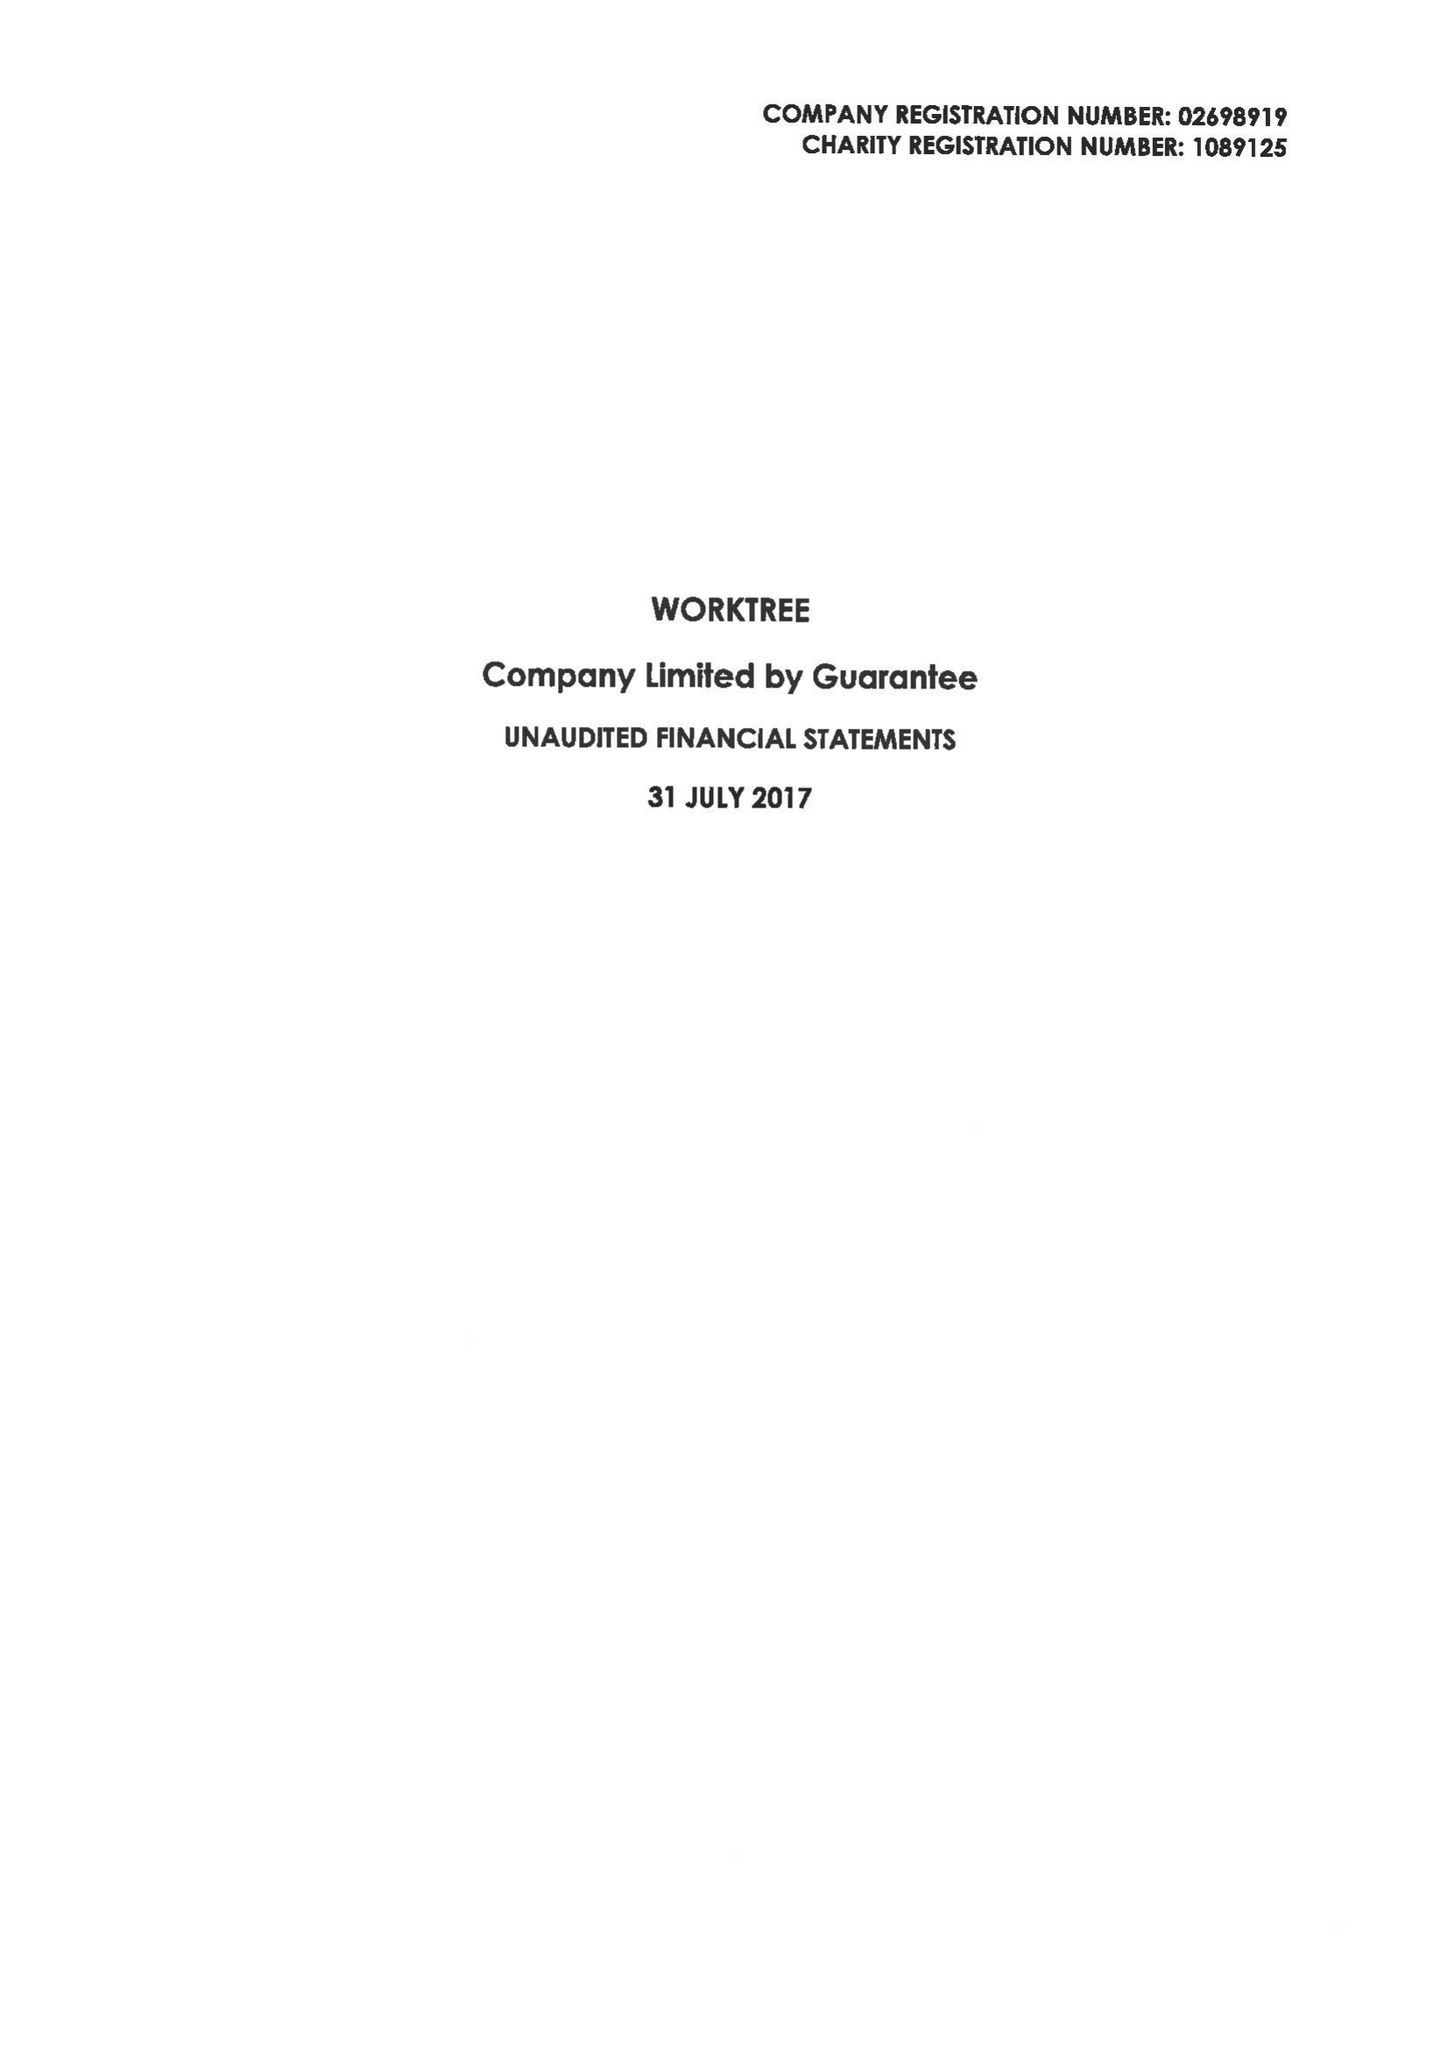What is the value for the address__postcode?
Answer the question using a single word or phrase. MK1 1LG 